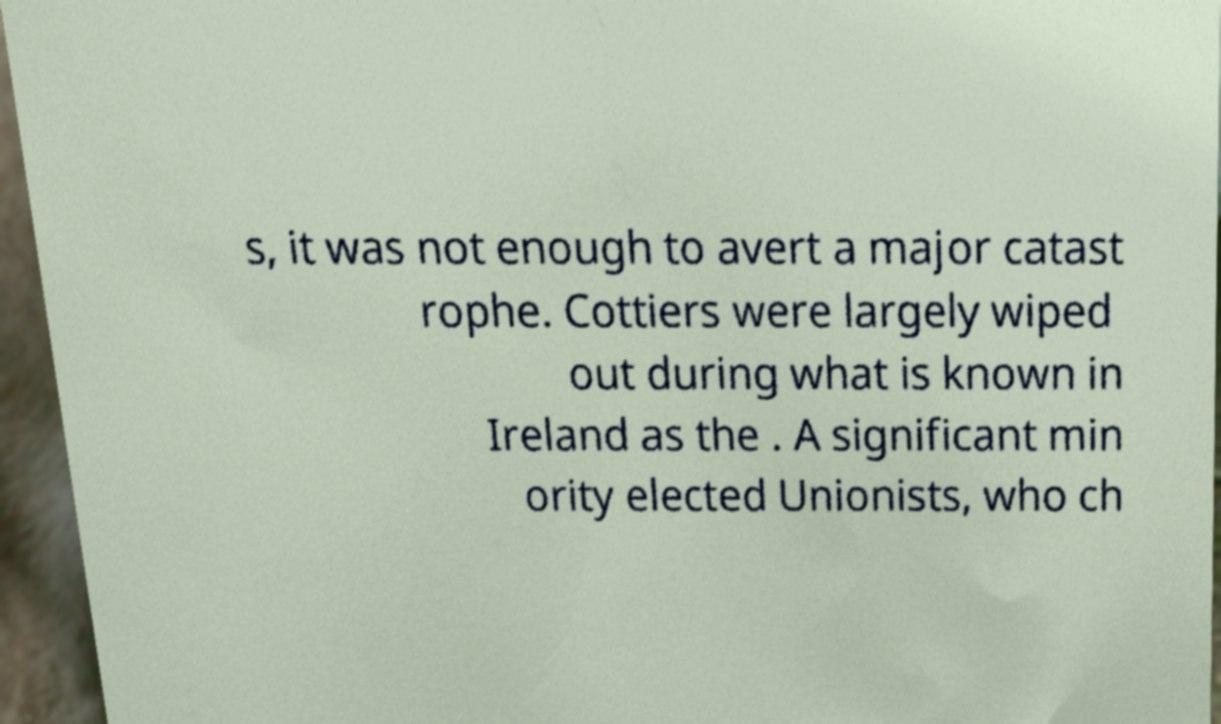There's text embedded in this image that I need extracted. Can you transcribe it verbatim? s, it was not enough to avert a major catast rophe. Cottiers were largely wiped out during what is known in Ireland as the . A significant min ority elected Unionists, who ch 